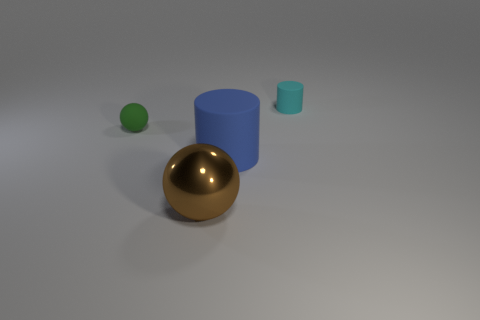Add 3 small cyan cylinders. How many objects exist? 7 Subtract 1 green balls. How many objects are left? 3 Subtract all big blue matte things. Subtract all small green balls. How many objects are left? 2 Add 3 objects. How many objects are left? 7 Add 3 small objects. How many small objects exist? 5 